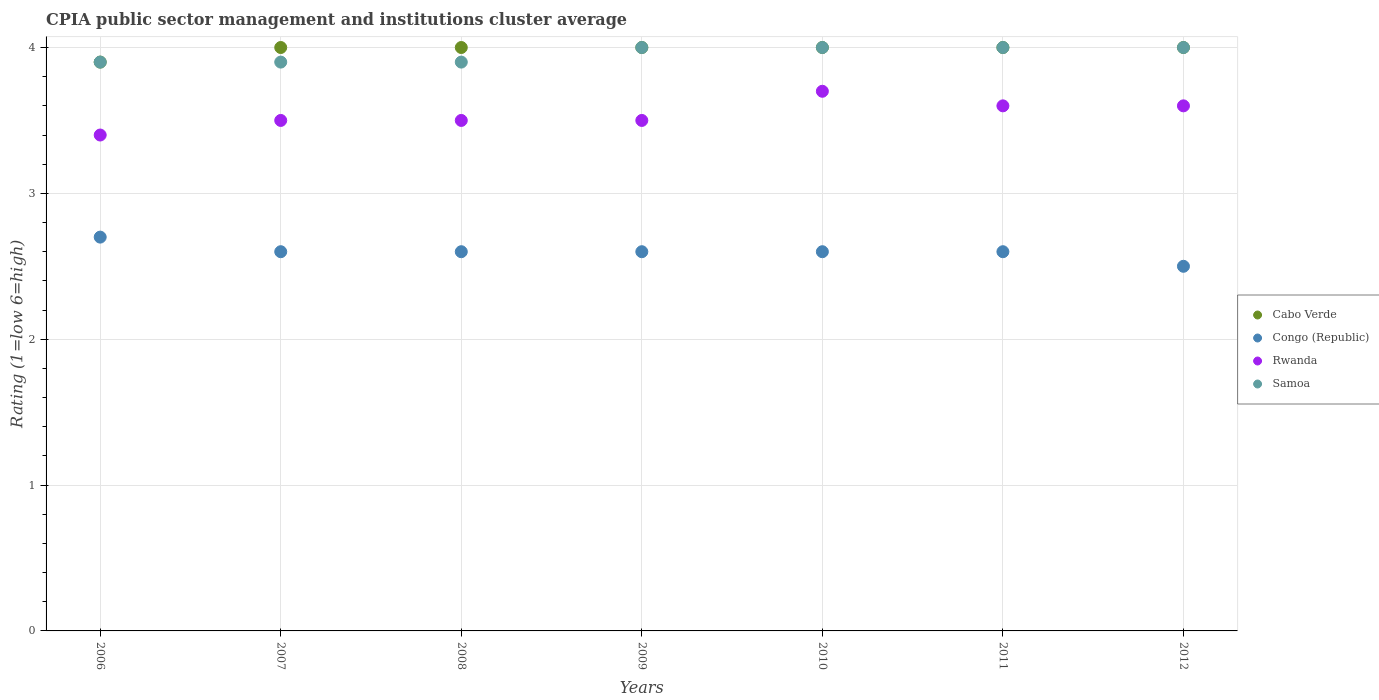How many different coloured dotlines are there?
Make the answer very short. 4. Is the number of dotlines equal to the number of legend labels?
Keep it short and to the point. Yes. What is the CPIA rating in Rwanda in 2012?
Offer a terse response. 3.6. In which year was the CPIA rating in Rwanda minimum?
Your answer should be very brief. 2006. What is the total CPIA rating in Rwanda in the graph?
Offer a terse response. 24.8. What is the difference between the CPIA rating in Samoa in 2008 and that in 2009?
Provide a succinct answer. -0.1. What is the difference between the CPIA rating in Congo (Republic) in 2009 and the CPIA rating in Samoa in 2007?
Provide a succinct answer. -1.3. What is the average CPIA rating in Samoa per year?
Your response must be concise. 3.96. In the year 2009, what is the difference between the CPIA rating in Congo (Republic) and CPIA rating in Cabo Verde?
Offer a very short reply. -1.4. In how many years, is the CPIA rating in Congo (Republic) greater than 0.4?
Offer a terse response. 7. Is the difference between the CPIA rating in Congo (Republic) in 2007 and 2008 greater than the difference between the CPIA rating in Cabo Verde in 2007 and 2008?
Your response must be concise. No. What is the difference between the highest and the second highest CPIA rating in Congo (Republic)?
Your answer should be compact. 0.1. What is the difference between the highest and the lowest CPIA rating in Rwanda?
Ensure brevity in your answer.  0.3. In how many years, is the CPIA rating in Congo (Republic) greater than the average CPIA rating in Congo (Republic) taken over all years?
Give a very brief answer. 1. Is it the case that in every year, the sum of the CPIA rating in Cabo Verde and CPIA rating in Congo (Republic)  is greater than the CPIA rating in Samoa?
Offer a very short reply. Yes. Is the CPIA rating in Congo (Republic) strictly less than the CPIA rating in Rwanda over the years?
Make the answer very short. Yes. How many dotlines are there?
Offer a terse response. 4. Does the graph contain any zero values?
Give a very brief answer. No. Does the graph contain grids?
Ensure brevity in your answer.  Yes. Where does the legend appear in the graph?
Offer a very short reply. Center right. How many legend labels are there?
Provide a succinct answer. 4. How are the legend labels stacked?
Make the answer very short. Vertical. What is the title of the graph?
Ensure brevity in your answer.  CPIA public sector management and institutions cluster average. Does "Samoa" appear as one of the legend labels in the graph?
Your response must be concise. Yes. What is the Rating (1=low 6=high) in Cabo Verde in 2006?
Keep it short and to the point. 3.9. What is the Rating (1=low 6=high) of Rwanda in 2006?
Offer a terse response. 3.4. What is the Rating (1=low 6=high) in Congo (Republic) in 2007?
Give a very brief answer. 2.6. What is the Rating (1=low 6=high) of Rwanda in 2007?
Ensure brevity in your answer.  3.5. What is the Rating (1=low 6=high) of Congo (Republic) in 2008?
Provide a succinct answer. 2.6. What is the Rating (1=low 6=high) in Samoa in 2008?
Your answer should be compact. 3.9. What is the Rating (1=low 6=high) of Congo (Republic) in 2010?
Your response must be concise. 2.6. What is the Rating (1=low 6=high) in Samoa in 2010?
Your answer should be compact. 4. What is the Rating (1=low 6=high) in Cabo Verde in 2011?
Provide a short and direct response. 4. What is the Rating (1=low 6=high) in Congo (Republic) in 2011?
Provide a succinct answer. 2.6. What is the Rating (1=low 6=high) of Cabo Verde in 2012?
Provide a succinct answer. 4. What is the Rating (1=low 6=high) of Samoa in 2012?
Offer a terse response. 4. Across all years, what is the maximum Rating (1=low 6=high) in Cabo Verde?
Your answer should be very brief. 4. Across all years, what is the maximum Rating (1=low 6=high) of Rwanda?
Your answer should be compact. 3.7. Across all years, what is the maximum Rating (1=low 6=high) of Samoa?
Give a very brief answer. 4. Across all years, what is the minimum Rating (1=low 6=high) in Cabo Verde?
Provide a short and direct response. 3.9. Across all years, what is the minimum Rating (1=low 6=high) in Rwanda?
Offer a terse response. 3.4. Across all years, what is the minimum Rating (1=low 6=high) in Samoa?
Your response must be concise. 3.9. What is the total Rating (1=low 6=high) in Cabo Verde in the graph?
Ensure brevity in your answer.  27.9. What is the total Rating (1=low 6=high) in Rwanda in the graph?
Offer a very short reply. 24.8. What is the total Rating (1=low 6=high) in Samoa in the graph?
Give a very brief answer. 27.7. What is the difference between the Rating (1=low 6=high) in Cabo Verde in 2006 and that in 2007?
Your response must be concise. -0.1. What is the difference between the Rating (1=low 6=high) in Rwanda in 2006 and that in 2007?
Keep it short and to the point. -0.1. What is the difference between the Rating (1=low 6=high) of Congo (Republic) in 2006 and that in 2008?
Offer a terse response. 0.1. What is the difference between the Rating (1=low 6=high) of Samoa in 2006 and that in 2008?
Your answer should be very brief. 0. What is the difference between the Rating (1=low 6=high) of Cabo Verde in 2006 and that in 2009?
Your answer should be compact. -0.1. What is the difference between the Rating (1=low 6=high) of Congo (Republic) in 2006 and that in 2009?
Your response must be concise. 0.1. What is the difference between the Rating (1=low 6=high) of Rwanda in 2006 and that in 2009?
Provide a short and direct response. -0.1. What is the difference between the Rating (1=low 6=high) of Cabo Verde in 2006 and that in 2010?
Offer a very short reply. -0.1. What is the difference between the Rating (1=low 6=high) of Congo (Republic) in 2006 and that in 2010?
Make the answer very short. 0.1. What is the difference between the Rating (1=low 6=high) in Samoa in 2006 and that in 2010?
Ensure brevity in your answer.  -0.1. What is the difference between the Rating (1=low 6=high) in Congo (Republic) in 2006 and that in 2011?
Keep it short and to the point. 0.1. What is the difference between the Rating (1=low 6=high) in Cabo Verde in 2006 and that in 2012?
Give a very brief answer. -0.1. What is the difference between the Rating (1=low 6=high) of Congo (Republic) in 2006 and that in 2012?
Your answer should be very brief. 0.2. What is the difference between the Rating (1=low 6=high) of Samoa in 2006 and that in 2012?
Your answer should be very brief. -0.1. What is the difference between the Rating (1=low 6=high) of Congo (Republic) in 2007 and that in 2008?
Keep it short and to the point. 0. What is the difference between the Rating (1=low 6=high) of Rwanda in 2007 and that in 2008?
Keep it short and to the point. 0. What is the difference between the Rating (1=low 6=high) of Samoa in 2007 and that in 2008?
Provide a short and direct response. 0. What is the difference between the Rating (1=low 6=high) of Cabo Verde in 2007 and that in 2009?
Your response must be concise. 0. What is the difference between the Rating (1=low 6=high) in Congo (Republic) in 2007 and that in 2009?
Give a very brief answer. 0. What is the difference between the Rating (1=low 6=high) in Rwanda in 2007 and that in 2009?
Your answer should be compact. 0. What is the difference between the Rating (1=low 6=high) in Cabo Verde in 2007 and that in 2010?
Your response must be concise. 0. What is the difference between the Rating (1=low 6=high) of Congo (Republic) in 2007 and that in 2010?
Give a very brief answer. 0. What is the difference between the Rating (1=low 6=high) of Congo (Republic) in 2007 and that in 2011?
Keep it short and to the point. 0. What is the difference between the Rating (1=low 6=high) in Rwanda in 2007 and that in 2011?
Keep it short and to the point. -0.1. What is the difference between the Rating (1=low 6=high) in Samoa in 2007 and that in 2011?
Ensure brevity in your answer.  -0.1. What is the difference between the Rating (1=low 6=high) of Cabo Verde in 2007 and that in 2012?
Ensure brevity in your answer.  0. What is the difference between the Rating (1=low 6=high) of Congo (Republic) in 2007 and that in 2012?
Keep it short and to the point. 0.1. What is the difference between the Rating (1=low 6=high) of Rwanda in 2007 and that in 2012?
Provide a short and direct response. -0.1. What is the difference between the Rating (1=low 6=high) of Cabo Verde in 2008 and that in 2009?
Your response must be concise. 0. What is the difference between the Rating (1=low 6=high) in Congo (Republic) in 2008 and that in 2009?
Provide a short and direct response. 0. What is the difference between the Rating (1=low 6=high) of Rwanda in 2008 and that in 2009?
Your answer should be compact. 0. What is the difference between the Rating (1=low 6=high) in Cabo Verde in 2008 and that in 2010?
Keep it short and to the point. 0. What is the difference between the Rating (1=low 6=high) in Congo (Republic) in 2008 and that in 2010?
Provide a succinct answer. 0. What is the difference between the Rating (1=low 6=high) of Rwanda in 2008 and that in 2010?
Your response must be concise. -0.2. What is the difference between the Rating (1=low 6=high) of Samoa in 2008 and that in 2011?
Ensure brevity in your answer.  -0.1. What is the difference between the Rating (1=low 6=high) in Cabo Verde in 2008 and that in 2012?
Offer a very short reply. 0. What is the difference between the Rating (1=low 6=high) of Rwanda in 2008 and that in 2012?
Offer a terse response. -0.1. What is the difference between the Rating (1=low 6=high) of Samoa in 2008 and that in 2012?
Ensure brevity in your answer.  -0.1. What is the difference between the Rating (1=low 6=high) in Cabo Verde in 2009 and that in 2010?
Your response must be concise. 0. What is the difference between the Rating (1=low 6=high) of Congo (Republic) in 2009 and that in 2010?
Ensure brevity in your answer.  0. What is the difference between the Rating (1=low 6=high) in Cabo Verde in 2009 and that in 2011?
Your answer should be very brief. 0. What is the difference between the Rating (1=low 6=high) of Congo (Republic) in 2010 and that in 2011?
Ensure brevity in your answer.  0. What is the difference between the Rating (1=low 6=high) in Congo (Republic) in 2010 and that in 2012?
Your response must be concise. 0.1. What is the difference between the Rating (1=low 6=high) of Cabo Verde in 2011 and that in 2012?
Give a very brief answer. 0. What is the difference between the Rating (1=low 6=high) in Rwanda in 2011 and that in 2012?
Provide a short and direct response. 0. What is the difference between the Rating (1=low 6=high) of Samoa in 2011 and that in 2012?
Give a very brief answer. 0. What is the difference between the Rating (1=low 6=high) in Cabo Verde in 2006 and the Rating (1=low 6=high) in Congo (Republic) in 2007?
Make the answer very short. 1.3. What is the difference between the Rating (1=low 6=high) in Congo (Republic) in 2006 and the Rating (1=low 6=high) in Rwanda in 2007?
Give a very brief answer. -0.8. What is the difference between the Rating (1=low 6=high) of Congo (Republic) in 2006 and the Rating (1=low 6=high) of Samoa in 2007?
Ensure brevity in your answer.  -1.2. What is the difference between the Rating (1=low 6=high) of Rwanda in 2006 and the Rating (1=low 6=high) of Samoa in 2007?
Offer a very short reply. -0.5. What is the difference between the Rating (1=low 6=high) of Cabo Verde in 2006 and the Rating (1=low 6=high) of Congo (Republic) in 2008?
Offer a very short reply. 1.3. What is the difference between the Rating (1=low 6=high) in Cabo Verde in 2006 and the Rating (1=low 6=high) in Rwanda in 2008?
Your answer should be very brief. 0.4. What is the difference between the Rating (1=low 6=high) in Congo (Republic) in 2006 and the Rating (1=low 6=high) in Samoa in 2008?
Give a very brief answer. -1.2. What is the difference between the Rating (1=low 6=high) in Rwanda in 2006 and the Rating (1=low 6=high) in Samoa in 2008?
Keep it short and to the point. -0.5. What is the difference between the Rating (1=low 6=high) in Cabo Verde in 2006 and the Rating (1=low 6=high) in Rwanda in 2009?
Your answer should be compact. 0.4. What is the difference between the Rating (1=low 6=high) in Congo (Republic) in 2006 and the Rating (1=low 6=high) in Rwanda in 2009?
Provide a succinct answer. -0.8. What is the difference between the Rating (1=low 6=high) of Rwanda in 2006 and the Rating (1=low 6=high) of Samoa in 2009?
Provide a short and direct response. -0.6. What is the difference between the Rating (1=low 6=high) in Cabo Verde in 2006 and the Rating (1=low 6=high) in Congo (Republic) in 2010?
Make the answer very short. 1.3. What is the difference between the Rating (1=low 6=high) of Cabo Verde in 2006 and the Rating (1=low 6=high) of Samoa in 2010?
Your answer should be compact. -0.1. What is the difference between the Rating (1=low 6=high) in Congo (Republic) in 2006 and the Rating (1=low 6=high) in Rwanda in 2010?
Provide a short and direct response. -1. What is the difference between the Rating (1=low 6=high) in Congo (Republic) in 2006 and the Rating (1=low 6=high) in Samoa in 2010?
Ensure brevity in your answer.  -1.3. What is the difference between the Rating (1=low 6=high) of Congo (Republic) in 2006 and the Rating (1=low 6=high) of Rwanda in 2011?
Your answer should be very brief. -0.9. What is the difference between the Rating (1=low 6=high) in Cabo Verde in 2006 and the Rating (1=low 6=high) in Samoa in 2012?
Your answer should be very brief. -0.1. What is the difference between the Rating (1=low 6=high) in Congo (Republic) in 2006 and the Rating (1=low 6=high) in Rwanda in 2012?
Ensure brevity in your answer.  -0.9. What is the difference between the Rating (1=low 6=high) in Congo (Republic) in 2006 and the Rating (1=low 6=high) in Samoa in 2012?
Offer a very short reply. -1.3. What is the difference between the Rating (1=low 6=high) in Rwanda in 2006 and the Rating (1=low 6=high) in Samoa in 2012?
Provide a succinct answer. -0.6. What is the difference between the Rating (1=low 6=high) in Cabo Verde in 2007 and the Rating (1=low 6=high) in Rwanda in 2008?
Offer a terse response. 0.5. What is the difference between the Rating (1=low 6=high) of Congo (Republic) in 2007 and the Rating (1=low 6=high) of Rwanda in 2008?
Give a very brief answer. -0.9. What is the difference between the Rating (1=low 6=high) of Cabo Verde in 2007 and the Rating (1=low 6=high) of Congo (Republic) in 2009?
Offer a terse response. 1.4. What is the difference between the Rating (1=low 6=high) in Cabo Verde in 2007 and the Rating (1=low 6=high) in Rwanda in 2009?
Give a very brief answer. 0.5. What is the difference between the Rating (1=low 6=high) of Cabo Verde in 2007 and the Rating (1=low 6=high) of Samoa in 2009?
Ensure brevity in your answer.  0. What is the difference between the Rating (1=low 6=high) of Congo (Republic) in 2007 and the Rating (1=low 6=high) of Samoa in 2009?
Provide a short and direct response. -1.4. What is the difference between the Rating (1=low 6=high) of Cabo Verde in 2007 and the Rating (1=low 6=high) of Rwanda in 2010?
Your response must be concise. 0.3. What is the difference between the Rating (1=low 6=high) in Congo (Republic) in 2007 and the Rating (1=low 6=high) in Rwanda in 2010?
Your response must be concise. -1.1. What is the difference between the Rating (1=low 6=high) in Congo (Republic) in 2007 and the Rating (1=low 6=high) in Samoa in 2010?
Keep it short and to the point. -1.4. What is the difference between the Rating (1=low 6=high) of Congo (Republic) in 2007 and the Rating (1=low 6=high) of Samoa in 2011?
Offer a very short reply. -1.4. What is the difference between the Rating (1=low 6=high) of Rwanda in 2007 and the Rating (1=low 6=high) of Samoa in 2011?
Keep it short and to the point. -0.5. What is the difference between the Rating (1=low 6=high) of Cabo Verde in 2007 and the Rating (1=low 6=high) of Congo (Republic) in 2012?
Keep it short and to the point. 1.5. What is the difference between the Rating (1=low 6=high) in Cabo Verde in 2007 and the Rating (1=low 6=high) in Samoa in 2012?
Your response must be concise. 0. What is the difference between the Rating (1=low 6=high) of Congo (Republic) in 2007 and the Rating (1=low 6=high) of Rwanda in 2012?
Your answer should be compact. -1. What is the difference between the Rating (1=low 6=high) of Congo (Republic) in 2007 and the Rating (1=low 6=high) of Samoa in 2012?
Your response must be concise. -1.4. What is the difference between the Rating (1=low 6=high) of Cabo Verde in 2008 and the Rating (1=low 6=high) of Samoa in 2009?
Your response must be concise. 0. What is the difference between the Rating (1=low 6=high) in Congo (Republic) in 2008 and the Rating (1=low 6=high) in Rwanda in 2009?
Your response must be concise. -0.9. What is the difference between the Rating (1=low 6=high) of Congo (Republic) in 2008 and the Rating (1=low 6=high) of Samoa in 2009?
Offer a terse response. -1.4. What is the difference between the Rating (1=low 6=high) in Cabo Verde in 2008 and the Rating (1=low 6=high) in Congo (Republic) in 2010?
Offer a very short reply. 1.4. What is the difference between the Rating (1=low 6=high) of Cabo Verde in 2008 and the Rating (1=low 6=high) of Samoa in 2010?
Your response must be concise. 0. What is the difference between the Rating (1=low 6=high) in Congo (Republic) in 2008 and the Rating (1=low 6=high) in Rwanda in 2010?
Ensure brevity in your answer.  -1.1. What is the difference between the Rating (1=low 6=high) in Congo (Republic) in 2008 and the Rating (1=low 6=high) in Samoa in 2010?
Provide a succinct answer. -1.4. What is the difference between the Rating (1=low 6=high) of Rwanda in 2008 and the Rating (1=low 6=high) of Samoa in 2010?
Keep it short and to the point. -0.5. What is the difference between the Rating (1=low 6=high) in Rwanda in 2008 and the Rating (1=low 6=high) in Samoa in 2011?
Your answer should be very brief. -0.5. What is the difference between the Rating (1=low 6=high) of Cabo Verde in 2008 and the Rating (1=low 6=high) of Rwanda in 2012?
Keep it short and to the point. 0.4. What is the difference between the Rating (1=low 6=high) of Cabo Verde in 2008 and the Rating (1=low 6=high) of Samoa in 2012?
Your response must be concise. 0. What is the difference between the Rating (1=low 6=high) in Cabo Verde in 2009 and the Rating (1=low 6=high) in Samoa in 2010?
Offer a terse response. 0. What is the difference between the Rating (1=low 6=high) of Congo (Republic) in 2009 and the Rating (1=low 6=high) of Samoa in 2010?
Your answer should be compact. -1.4. What is the difference between the Rating (1=low 6=high) in Cabo Verde in 2009 and the Rating (1=low 6=high) in Samoa in 2011?
Ensure brevity in your answer.  0. What is the difference between the Rating (1=low 6=high) of Rwanda in 2009 and the Rating (1=low 6=high) of Samoa in 2011?
Your response must be concise. -0.5. What is the difference between the Rating (1=low 6=high) in Cabo Verde in 2009 and the Rating (1=low 6=high) in Congo (Republic) in 2012?
Offer a terse response. 1.5. What is the difference between the Rating (1=low 6=high) in Cabo Verde in 2009 and the Rating (1=low 6=high) in Rwanda in 2012?
Offer a terse response. 0.4. What is the difference between the Rating (1=low 6=high) in Cabo Verde in 2009 and the Rating (1=low 6=high) in Samoa in 2012?
Your answer should be compact. 0. What is the difference between the Rating (1=low 6=high) in Rwanda in 2009 and the Rating (1=low 6=high) in Samoa in 2012?
Make the answer very short. -0.5. What is the difference between the Rating (1=low 6=high) of Cabo Verde in 2010 and the Rating (1=low 6=high) of Congo (Republic) in 2011?
Ensure brevity in your answer.  1.4. What is the difference between the Rating (1=low 6=high) of Congo (Republic) in 2010 and the Rating (1=low 6=high) of Rwanda in 2011?
Your answer should be compact. -1. What is the difference between the Rating (1=low 6=high) of Congo (Republic) in 2010 and the Rating (1=low 6=high) of Samoa in 2011?
Offer a terse response. -1.4. What is the difference between the Rating (1=low 6=high) in Cabo Verde in 2010 and the Rating (1=low 6=high) in Congo (Republic) in 2012?
Offer a terse response. 1.5. What is the difference between the Rating (1=low 6=high) of Cabo Verde in 2010 and the Rating (1=low 6=high) of Rwanda in 2012?
Ensure brevity in your answer.  0.4. What is the difference between the Rating (1=low 6=high) of Cabo Verde in 2010 and the Rating (1=low 6=high) of Samoa in 2012?
Your answer should be compact. 0. What is the difference between the Rating (1=low 6=high) of Cabo Verde in 2011 and the Rating (1=low 6=high) of Congo (Republic) in 2012?
Give a very brief answer. 1.5. What is the difference between the Rating (1=low 6=high) in Cabo Verde in 2011 and the Rating (1=low 6=high) in Rwanda in 2012?
Provide a succinct answer. 0.4. What is the difference between the Rating (1=low 6=high) of Congo (Republic) in 2011 and the Rating (1=low 6=high) of Rwanda in 2012?
Your answer should be very brief. -1. What is the difference between the Rating (1=low 6=high) of Rwanda in 2011 and the Rating (1=low 6=high) of Samoa in 2012?
Offer a very short reply. -0.4. What is the average Rating (1=low 6=high) in Cabo Verde per year?
Ensure brevity in your answer.  3.99. What is the average Rating (1=low 6=high) in Rwanda per year?
Your answer should be compact. 3.54. What is the average Rating (1=low 6=high) in Samoa per year?
Your answer should be very brief. 3.96. In the year 2006, what is the difference between the Rating (1=low 6=high) in Cabo Verde and Rating (1=low 6=high) in Congo (Republic)?
Keep it short and to the point. 1.2. In the year 2006, what is the difference between the Rating (1=low 6=high) in Cabo Verde and Rating (1=low 6=high) in Rwanda?
Give a very brief answer. 0.5. In the year 2006, what is the difference between the Rating (1=low 6=high) in Congo (Republic) and Rating (1=low 6=high) in Rwanda?
Your answer should be compact. -0.7. In the year 2006, what is the difference between the Rating (1=low 6=high) in Congo (Republic) and Rating (1=low 6=high) in Samoa?
Your answer should be very brief. -1.2. In the year 2007, what is the difference between the Rating (1=low 6=high) of Cabo Verde and Rating (1=low 6=high) of Rwanda?
Give a very brief answer. 0.5. In the year 2007, what is the difference between the Rating (1=low 6=high) of Cabo Verde and Rating (1=low 6=high) of Samoa?
Offer a very short reply. 0.1. In the year 2007, what is the difference between the Rating (1=low 6=high) of Congo (Republic) and Rating (1=low 6=high) of Samoa?
Your answer should be very brief. -1.3. In the year 2007, what is the difference between the Rating (1=low 6=high) of Rwanda and Rating (1=low 6=high) of Samoa?
Your answer should be very brief. -0.4. In the year 2008, what is the difference between the Rating (1=low 6=high) in Cabo Verde and Rating (1=low 6=high) in Samoa?
Provide a short and direct response. 0.1. In the year 2009, what is the difference between the Rating (1=low 6=high) in Cabo Verde and Rating (1=low 6=high) in Congo (Republic)?
Provide a succinct answer. 1.4. In the year 2009, what is the difference between the Rating (1=low 6=high) of Cabo Verde and Rating (1=low 6=high) of Samoa?
Keep it short and to the point. 0. In the year 2009, what is the difference between the Rating (1=low 6=high) of Congo (Republic) and Rating (1=low 6=high) of Rwanda?
Provide a succinct answer. -0.9. In the year 2009, what is the difference between the Rating (1=low 6=high) of Congo (Republic) and Rating (1=low 6=high) of Samoa?
Your answer should be very brief. -1.4. In the year 2009, what is the difference between the Rating (1=low 6=high) in Rwanda and Rating (1=low 6=high) in Samoa?
Give a very brief answer. -0.5. In the year 2010, what is the difference between the Rating (1=low 6=high) of Cabo Verde and Rating (1=low 6=high) of Congo (Republic)?
Provide a succinct answer. 1.4. In the year 2010, what is the difference between the Rating (1=low 6=high) of Cabo Verde and Rating (1=low 6=high) of Rwanda?
Offer a terse response. 0.3. In the year 2010, what is the difference between the Rating (1=low 6=high) of Cabo Verde and Rating (1=low 6=high) of Samoa?
Offer a terse response. 0. In the year 2010, what is the difference between the Rating (1=low 6=high) of Congo (Republic) and Rating (1=low 6=high) of Samoa?
Offer a very short reply. -1.4. In the year 2011, what is the difference between the Rating (1=low 6=high) in Cabo Verde and Rating (1=low 6=high) in Congo (Republic)?
Offer a very short reply. 1.4. In the year 2011, what is the difference between the Rating (1=low 6=high) in Cabo Verde and Rating (1=low 6=high) in Rwanda?
Offer a very short reply. 0.4. In the year 2011, what is the difference between the Rating (1=low 6=high) of Congo (Republic) and Rating (1=low 6=high) of Rwanda?
Offer a terse response. -1. In the year 2011, what is the difference between the Rating (1=low 6=high) in Congo (Republic) and Rating (1=low 6=high) in Samoa?
Provide a short and direct response. -1.4. In the year 2011, what is the difference between the Rating (1=low 6=high) of Rwanda and Rating (1=low 6=high) of Samoa?
Your answer should be very brief. -0.4. In the year 2012, what is the difference between the Rating (1=low 6=high) of Cabo Verde and Rating (1=low 6=high) of Congo (Republic)?
Your response must be concise. 1.5. In the year 2012, what is the difference between the Rating (1=low 6=high) of Cabo Verde and Rating (1=low 6=high) of Samoa?
Your response must be concise. 0. In the year 2012, what is the difference between the Rating (1=low 6=high) in Congo (Republic) and Rating (1=low 6=high) in Samoa?
Your answer should be very brief. -1.5. In the year 2012, what is the difference between the Rating (1=low 6=high) in Rwanda and Rating (1=low 6=high) in Samoa?
Your answer should be compact. -0.4. What is the ratio of the Rating (1=low 6=high) of Cabo Verde in 2006 to that in 2007?
Your answer should be compact. 0.97. What is the ratio of the Rating (1=low 6=high) of Rwanda in 2006 to that in 2007?
Make the answer very short. 0.97. What is the ratio of the Rating (1=low 6=high) of Samoa in 2006 to that in 2007?
Offer a very short reply. 1. What is the ratio of the Rating (1=low 6=high) in Cabo Verde in 2006 to that in 2008?
Provide a short and direct response. 0.97. What is the ratio of the Rating (1=low 6=high) in Rwanda in 2006 to that in 2008?
Give a very brief answer. 0.97. What is the ratio of the Rating (1=low 6=high) in Cabo Verde in 2006 to that in 2009?
Your answer should be very brief. 0.97. What is the ratio of the Rating (1=low 6=high) in Rwanda in 2006 to that in 2009?
Provide a short and direct response. 0.97. What is the ratio of the Rating (1=low 6=high) of Samoa in 2006 to that in 2009?
Offer a terse response. 0.97. What is the ratio of the Rating (1=low 6=high) in Rwanda in 2006 to that in 2010?
Give a very brief answer. 0.92. What is the ratio of the Rating (1=low 6=high) in Cabo Verde in 2006 to that in 2011?
Make the answer very short. 0.97. What is the ratio of the Rating (1=low 6=high) of Rwanda in 2006 to that in 2011?
Your answer should be compact. 0.94. What is the ratio of the Rating (1=low 6=high) in Congo (Republic) in 2006 to that in 2012?
Ensure brevity in your answer.  1.08. What is the ratio of the Rating (1=low 6=high) in Samoa in 2006 to that in 2012?
Your answer should be very brief. 0.97. What is the ratio of the Rating (1=low 6=high) in Cabo Verde in 2007 to that in 2008?
Offer a very short reply. 1. What is the ratio of the Rating (1=low 6=high) of Cabo Verde in 2007 to that in 2009?
Your response must be concise. 1. What is the ratio of the Rating (1=low 6=high) in Rwanda in 2007 to that in 2009?
Make the answer very short. 1. What is the ratio of the Rating (1=low 6=high) of Rwanda in 2007 to that in 2010?
Your answer should be compact. 0.95. What is the ratio of the Rating (1=low 6=high) in Congo (Republic) in 2007 to that in 2011?
Your response must be concise. 1. What is the ratio of the Rating (1=low 6=high) of Rwanda in 2007 to that in 2011?
Your answer should be compact. 0.97. What is the ratio of the Rating (1=low 6=high) of Cabo Verde in 2007 to that in 2012?
Provide a short and direct response. 1. What is the ratio of the Rating (1=low 6=high) of Congo (Republic) in 2007 to that in 2012?
Keep it short and to the point. 1.04. What is the ratio of the Rating (1=low 6=high) of Rwanda in 2007 to that in 2012?
Give a very brief answer. 0.97. What is the ratio of the Rating (1=low 6=high) in Congo (Republic) in 2008 to that in 2009?
Offer a terse response. 1. What is the ratio of the Rating (1=low 6=high) in Samoa in 2008 to that in 2009?
Keep it short and to the point. 0.97. What is the ratio of the Rating (1=low 6=high) of Rwanda in 2008 to that in 2010?
Ensure brevity in your answer.  0.95. What is the ratio of the Rating (1=low 6=high) in Samoa in 2008 to that in 2010?
Make the answer very short. 0.97. What is the ratio of the Rating (1=low 6=high) in Cabo Verde in 2008 to that in 2011?
Ensure brevity in your answer.  1. What is the ratio of the Rating (1=low 6=high) in Congo (Republic) in 2008 to that in 2011?
Give a very brief answer. 1. What is the ratio of the Rating (1=low 6=high) of Rwanda in 2008 to that in 2011?
Provide a short and direct response. 0.97. What is the ratio of the Rating (1=low 6=high) of Cabo Verde in 2008 to that in 2012?
Offer a terse response. 1. What is the ratio of the Rating (1=low 6=high) of Congo (Republic) in 2008 to that in 2012?
Offer a terse response. 1.04. What is the ratio of the Rating (1=low 6=high) of Rwanda in 2008 to that in 2012?
Give a very brief answer. 0.97. What is the ratio of the Rating (1=low 6=high) in Congo (Republic) in 2009 to that in 2010?
Make the answer very short. 1. What is the ratio of the Rating (1=low 6=high) of Rwanda in 2009 to that in 2010?
Keep it short and to the point. 0.95. What is the ratio of the Rating (1=low 6=high) of Samoa in 2009 to that in 2010?
Your answer should be very brief. 1. What is the ratio of the Rating (1=low 6=high) in Cabo Verde in 2009 to that in 2011?
Your response must be concise. 1. What is the ratio of the Rating (1=low 6=high) in Rwanda in 2009 to that in 2011?
Your answer should be very brief. 0.97. What is the ratio of the Rating (1=low 6=high) in Samoa in 2009 to that in 2011?
Provide a short and direct response. 1. What is the ratio of the Rating (1=low 6=high) in Rwanda in 2009 to that in 2012?
Make the answer very short. 0.97. What is the ratio of the Rating (1=low 6=high) of Congo (Republic) in 2010 to that in 2011?
Provide a short and direct response. 1. What is the ratio of the Rating (1=low 6=high) of Rwanda in 2010 to that in 2011?
Offer a terse response. 1.03. What is the ratio of the Rating (1=low 6=high) in Samoa in 2010 to that in 2011?
Offer a very short reply. 1. What is the ratio of the Rating (1=low 6=high) in Cabo Verde in 2010 to that in 2012?
Provide a succinct answer. 1. What is the ratio of the Rating (1=low 6=high) in Rwanda in 2010 to that in 2012?
Make the answer very short. 1.03. What is the ratio of the Rating (1=low 6=high) in Rwanda in 2011 to that in 2012?
Give a very brief answer. 1. What is the difference between the highest and the second highest Rating (1=low 6=high) in Cabo Verde?
Ensure brevity in your answer.  0. What is the difference between the highest and the second highest Rating (1=low 6=high) in Congo (Republic)?
Ensure brevity in your answer.  0.1. What is the difference between the highest and the lowest Rating (1=low 6=high) of Cabo Verde?
Make the answer very short. 0.1. What is the difference between the highest and the lowest Rating (1=low 6=high) in Rwanda?
Offer a very short reply. 0.3. What is the difference between the highest and the lowest Rating (1=low 6=high) in Samoa?
Provide a short and direct response. 0.1. 